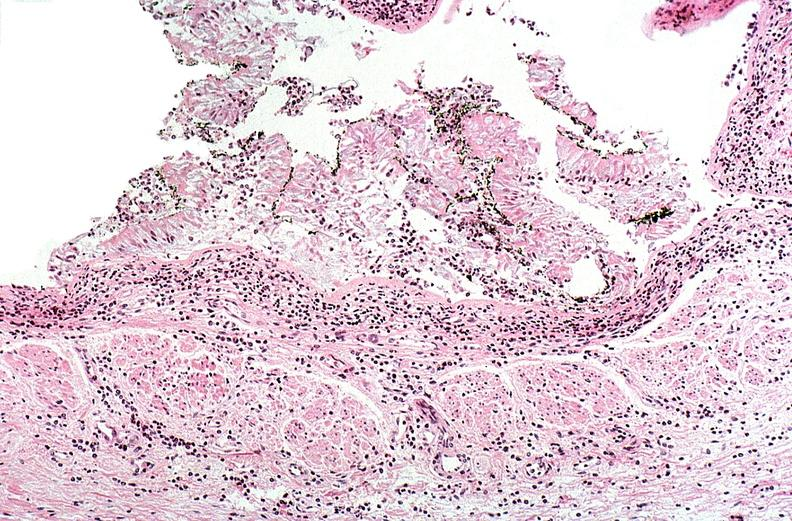what does this image show?
Answer the question using a single word or phrase. Thermal burn 